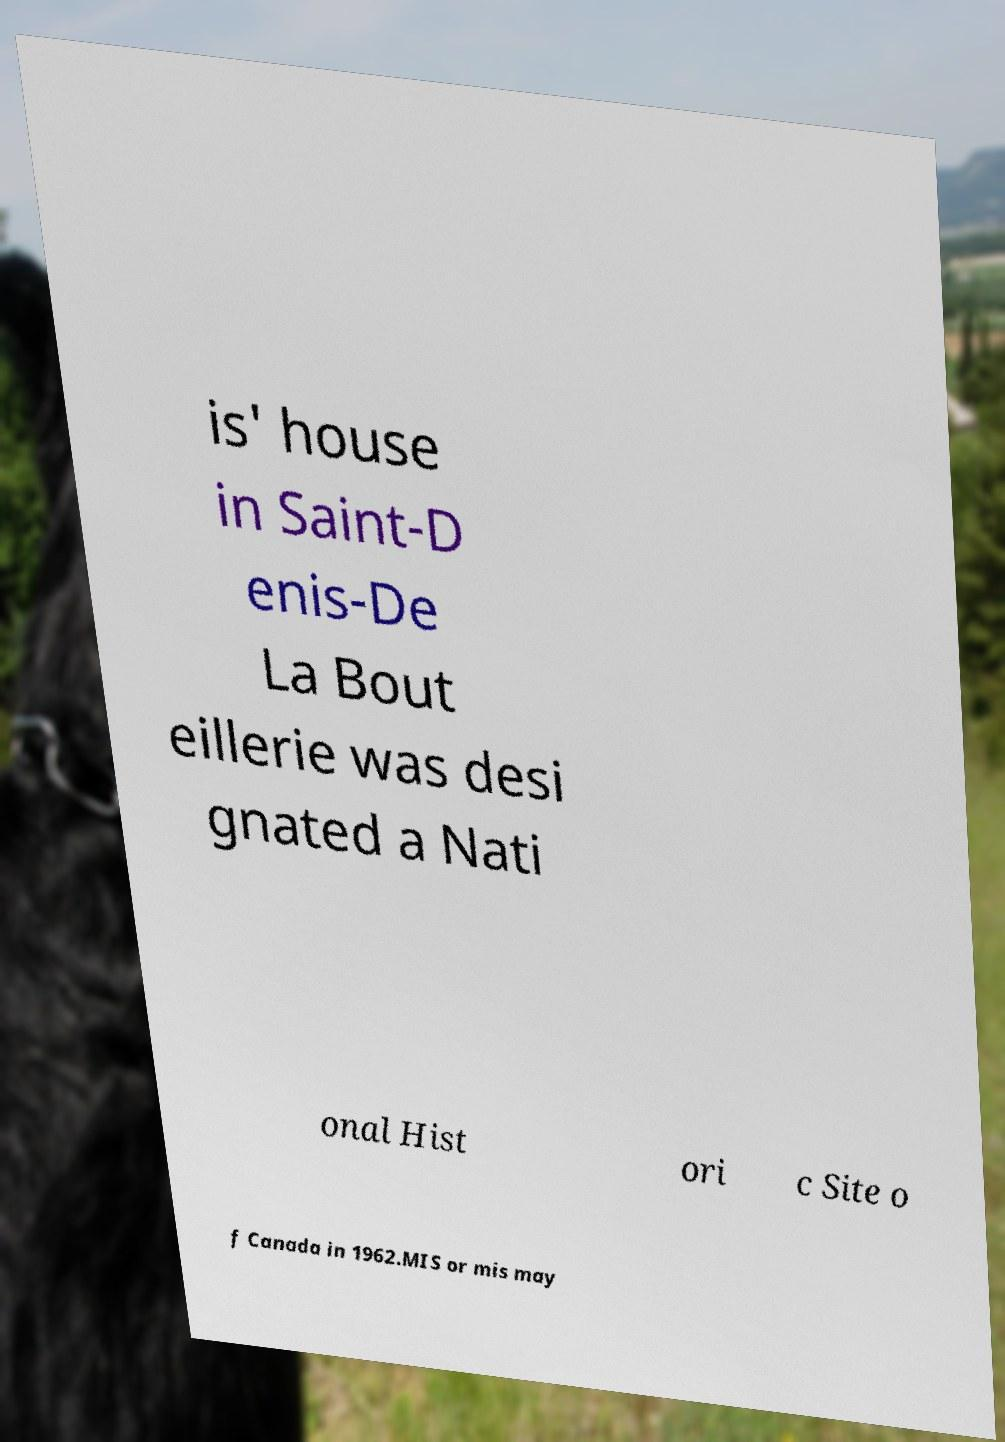There's text embedded in this image that I need extracted. Can you transcribe it verbatim? is' house in Saint-D enis-De La Bout eillerie was desi gnated a Nati onal Hist ori c Site o f Canada in 1962.MIS or mis may 